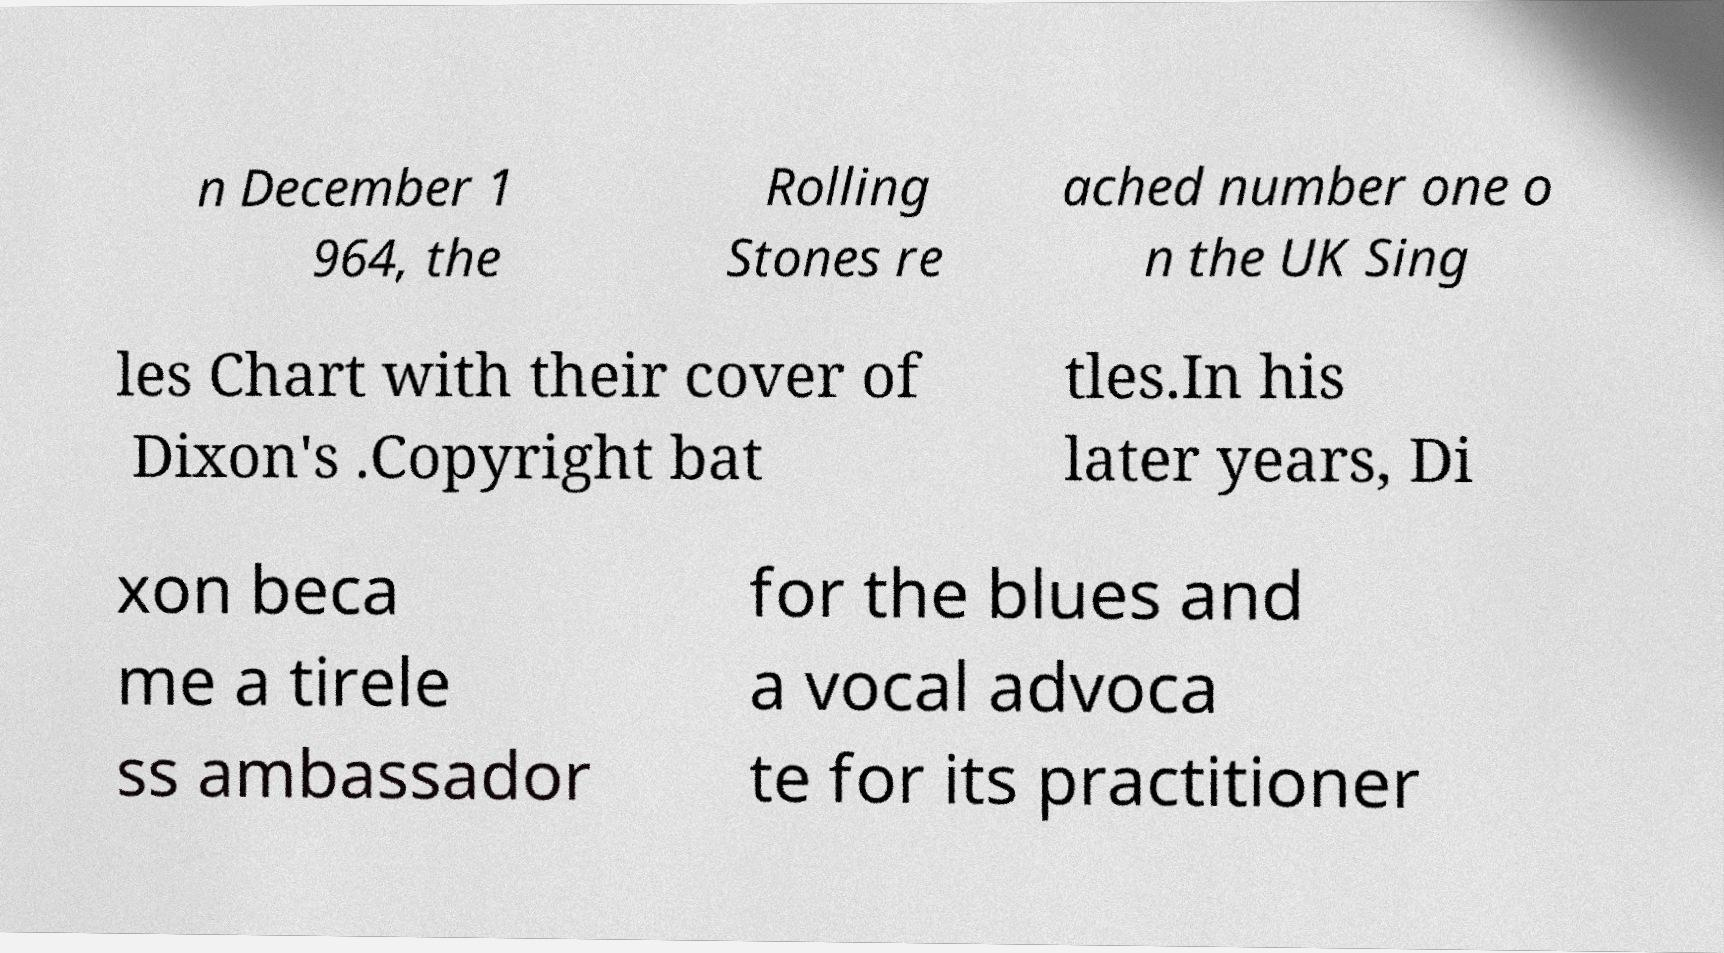What messages or text are displayed in this image? I need them in a readable, typed format. n December 1 964, the Rolling Stones re ached number one o n the UK Sing les Chart with their cover of Dixon's .Copyright bat tles.In his later years, Di xon beca me a tirele ss ambassador for the blues and a vocal advoca te for its practitioner 